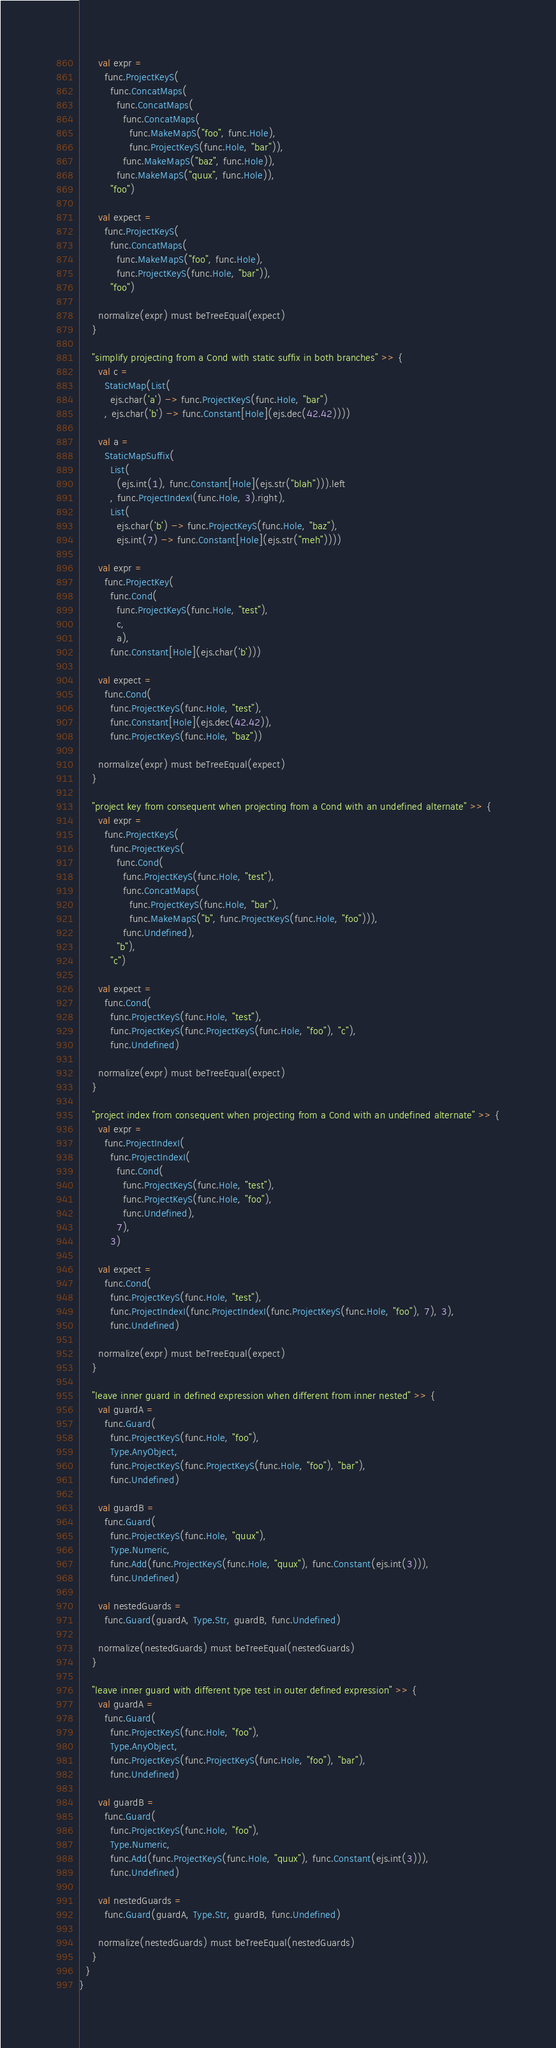<code> <loc_0><loc_0><loc_500><loc_500><_Scala_>      val expr =
        func.ProjectKeyS(
          func.ConcatMaps(
            func.ConcatMaps(
              func.ConcatMaps(
                func.MakeMapS("foo", func.Hole),
                func.ProjectKeyS(func.Hole, "bar")),
              func.MakeMapS("baz", func.Hole)),
            func.MakeMapS("quux", func.Hole)),
          "foo")

      val expect =
        func.ProjectKeyS(
          func.ConcatMaps(
            func.MakeMapS("foo", func.Hole),
            func.ProjectKeyS(func.Hole, "bar")),
          "foo")

      normalize(expr) must beTreeEqual(expect)
    }

    "simplify projecting from a Cond with static suffix in both branches" >> {
      val c =
        StaticMap(List(
          ejs.char('a') -> func.ProjectKeyS(func.Hole, "bar")
        , ejs.char('b') -> func.Constant[Hole](ejs.dec(42.42))))

      val a =
        StaticMapSuffix(
          List(
            (ejs.int(1), func.Constant[Hole](ejs.str("blah"))).left
          , func.ProjectIndexI(func.Hole, 3).right),
          List(
            ejs.char('b') -> func.ProjectKeyS(func.Hole, "baz"),
            ejs.int(7) -> func.Constant[Hole](ejs.str("meh"))))

      val expr =
        func.ProjectKey(
          func.Cond(
            func.ProjectKeyS(func.Hole, "test"),
            c,
            a),
          func.Constant[Hole](ejs.char('b')))

      val expect =
        func.Cond(
          func.ProjectKeyS(func.Hole, "test"),
          func.Constant[Hole](ejs.dec(42.42)),
          func.ProjectKeyS(func.Hole, "baz"))

      normalize(expr) must beTreeEqual(expect)
    }

    "project key from consequent when projecting from a Cond with an undefined alternate" >> {
      val expr =
        func.ProjectKeyS(
          func.ProjectKeyS(
            func.Cond(
              func.ProjectKeyS(func.Hole, "test"),
              func.ConcatMaps(
                func.ProjectKeyS(func.Hole, "bar"),
                func.MakeMapS("b", func.ProjectKeyS(func.Hole, "foo"))),
              func.Undefined),
            "b"),
          "c")

      val expect =
        func.Cond(
          func.ProjectKeyS(func.Hole, "test"),
          func.ProjectKeyS(func.ProjectKeyS(func.Hole, "foo"), "c"),
          func.Undefined)

      normalize(expr) must beTreeEqual(expect)
    }

    "project index from consequent when projecting from a Cond with an undefined alternate" >> {
      val expr =
        func.ProjectIndexI(
          func.ProjectIndexI(
            func.Cond(
              func.ProjectKeyS(func.Hole, "test"),
              func.ProjectKeyS(func.Hole, "foo"),
              func.Undefined),
            7),
          3)

      val expect =
        func.Cond(
          func.ProjectKeyS(func.Hole, "test"),
          func.ProjectIndexI(func.ProjectIndexI(func.ProjectKeyS(func.Hole, "foo"), 7), 3),
          func.Undefined)

      normalize(expr) must beTreeEqual(expect)
    }

    "leave inner guard in defined expression when different from inner nested" >> {
      val guardA =
        func.Guard(
          func.ProjectKeyS(func.Hole, "foo"),
          Type.AnyObject,
          func.ProjectKeyS(func.ProjectKeyS(func.Hole, "foo"), "bar"),
          func.Undefined)

      val guardB =
        func.Guard(
          func.ProjectKeyS(func.Hole, "quux"),
          Type.Numeric,
          func.Add(func.ProjectKeyS(func.Hole, "quux"), func.Constant(ejs.int(3))),
          func.Undefined)

      val nestedGuards =
        func.Guard(guardA, Type.Str, guardB, func.Undefined)

      normalize(nestedGuards) must beTreeEqual(nestedGuards)
    }

    "leave inner guard with different type test in outer defined expression" >> {
      val guardA =
        func.Guard(
          func.ProjectKeyS(func.Hole, "foo"),
          Type.AnyObject,
          func.ProjectKeyS(func.ProjectKeyS(func.Hole, "foo"), "bar"),
          func.Undefined)

      val guardB =
        func.Guard(
          func.ProjectKeyS(func.Hole, "foo"),
          Type.Numeric,
          func.Add(func.ProjectKeyS(func.Hole, "quux"), func.Constant(ejs.int(3))),
          func.Undefined)

      val nestedGuards =
        func.Guard(guardA, Type.Str, guardB, func.Undefined)

      normalize(nestedGuards) must beTreeEqual(nestedGuards)
    }
  }
}
</code> 